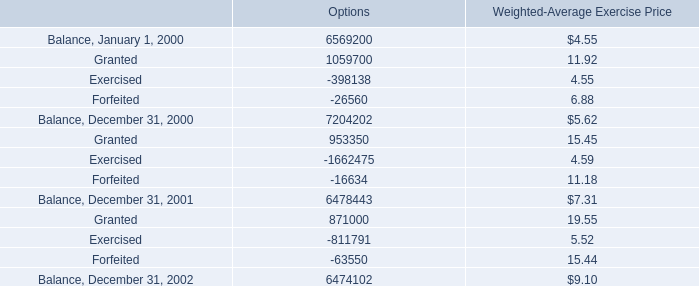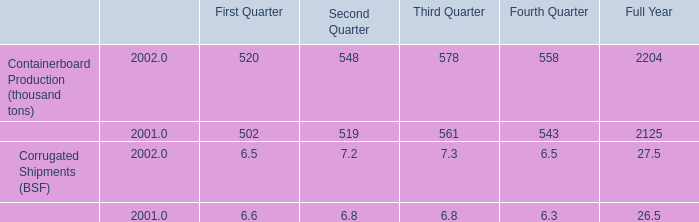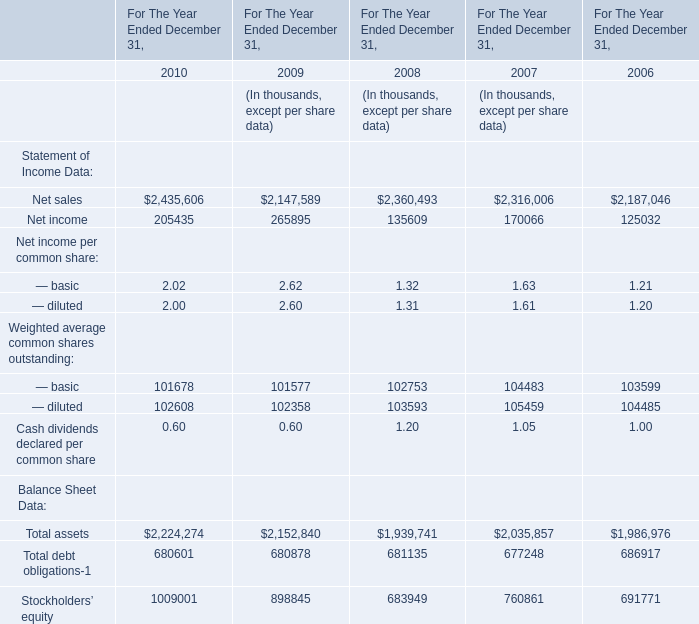What is the sum of Net sales of For The Year Ended December 31, 2010, and Balance, December 31, 2002 of Options ? 
Computations: (2435606.0 + 6474102.0)
Answer: 8909708.0. 